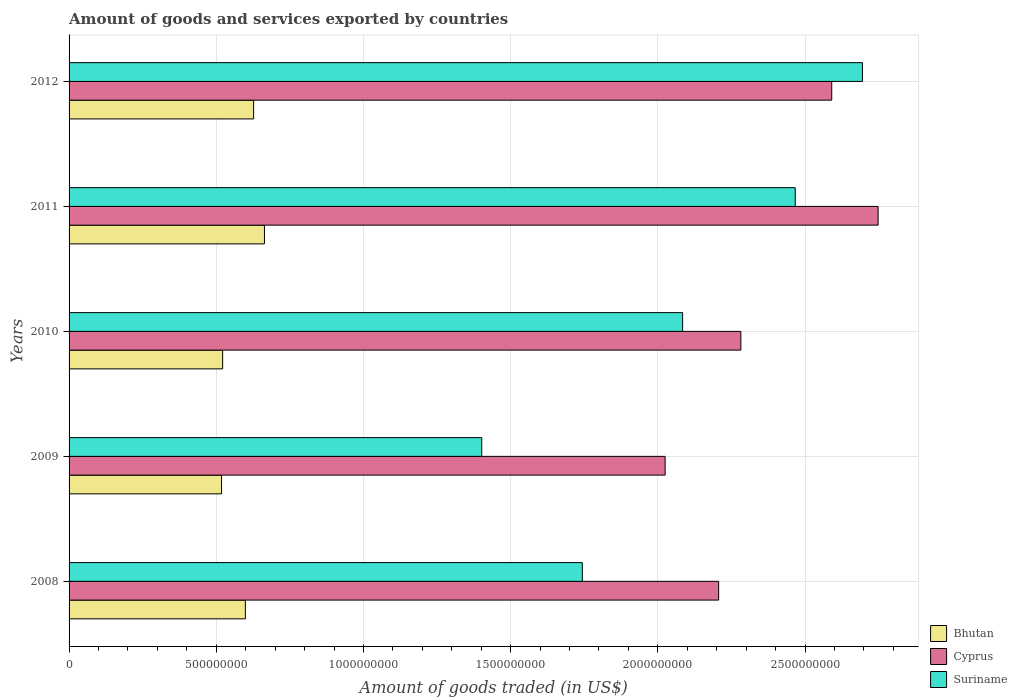How many groups of bars are there?
Keep it short and to the point. 5. Are the number of bars per tick equal to the number of legend labels?
Provide a short and direct response. Yes. Are the number of bars on each tick of the Y-axis equal?
Provide a succinct answer. Yes. What is the label of the 2nd group of bars from the top?
Your answer should be compact. 2011. What is the total amount of goods and services exported in Bhutan in 2012?
Provide a succinct answer. 6.27e+08. Across all years, what is the maximum total amount of goods and services exported in Bhutan?
Provide a succinct answer. 6.64e+08. Across all years, what is the minimum total amount of goods and services exported in Cyprus?
Your answer should be very brief. 2.02e+09. In which year was the total amount of goods and services exported in Bhutan minimum?
Make the answer very short. 2009. What is the total total amount of goods and services exported in Suriname in the graph?
Ensure brevity in your answer.  1.04e+1. What is the difference between the total amount of goods and services exported in Suriname in 2009 and that in 2010?
Provide a short and direct response. -6.82e+08. What is the difference between the total amount of goods and services exported in Cyprus in 2010 and the total amount of goods and services exported in Suriname in 2011?
Provide a succinct answer. -1.85e+08. What is the average total amount of goods and services exported in Bhutan per year?
Provide a succinct answer. 5.86e+08. In the year 2010, what is the difference between the total amount of goods and services exported in Cyprus and total amount of goods and services exported in Suriname?
Give a very brief answer. 1.98e+08. What is the ratio of the total amount of goods and services exported in Bhutan in 2009 to that in 2011?
Provide a short and direct response. 0.78. Is the total amount of goods and services exported in Bhutan in 2008 less than that in 2009?
Provide a succinct answer. No. Is the difference between the total amount of goods and services exported in Cyprus in 2008 and 2011 greater than the difference between the total amount of goods and services exported in Suriname in 2008 and 2011?
Your response must be concise. Yes. What is the difference between the highest and the second highest total amount of goods and services exported in Bhutan?
Provide a short and direct response. 3.68e+07. What is the difference between the highest and the lowest total amount of goods and services exported in Cyprus?
Offer a terse response. 7.23e+08. In how many years, is the total amount of goods and services exported in Suriname greater than the average total amount of goods and services exported in Suriname taken over all years?
Make the answer very short. 3. Is the sum of the total amount of goods and services exported in Suriname in 2008 and 2012 greater than the maximum total amount of goods and services exported in Bhutan across all years?
Make the answer very short. Yes. What does the 3rd bar from the top in 2009 represents?
Ensure brevity in your answer.  Bhutan. What does the 2nd bar from the bottom in 2009 represents?
Make the answer very short. Cyprus. How many bars are there?
Your response must be concise. 15. Are all the bars in the graph horizontal?
Ensure brevity in your answer.  Yes. How many years are there in the graph?
Your answer should be very brief. 5. Where does the legend appear in the graph?
Your response must be concise. Bottom right. How many legend labels are there?
Your response must be concise. 3. What is the title of the graph?
Provide a succinct answer. Amount of goods and services exported by countries. Does "Micronesia" appear as one of the legend labels in the graph?
Offer a very short reply. No. What is the label or title of the X-axis?
Give a very brief answer. Amount of goods traded (in US$). What is the label or title of the Y-axis?
Make the answer very short. Years. What is the Amount of goods traded (in US$) of Bhutan in 2008?
Offer a very short reply. 5.99e+08. What is the Amount of goods traded (in US$) of Cyprus in 2008?
Provide a short and direct response. 2.21e+09. What is the Amount of goods traded (in US$) in Suriname in 2008?
Give a very brief answer. 1.74e+09. What is the Amount of goods traded (in US$) in Bhutan in 2009?
Offer a very short reply. 5.18e+08. What is the Amount of goods traded (in US$) of Cyprus in 2009?
Your answer should be very brief. 2.02e+09. What is the Amount of goods traded (in US$) in Suriname in 2009?
Your answer should be compact. 1.40e+09. What is the Amount of goods traded (in US$) of Bhutan in 2010?
Make the answer very short. 5.22e+08. What is the Amount of goods traded (in US$) of Cyprus in 2010?
Provide a succinct answer. 2.28e+09. What is the Amount of goods traded (in US$) in Suriname in 2010?
Provide a succinct answer. 2.08e+09. What is the Amount of goods traded (in US$) of Bhutan in 2011?
Offer a very short reply. 6.64e+08. What is the Amount of goods traded (in US$) in Cyprus in 2011?
Your answer should be very brief. 2.75e+09. What is the Amount of goods traded (in US$) of Suriname in 2011?
Provide a short and direct response. 2.47e+09. What is the Amount of goods traded (in US$) in Bhutan in 2012?
Your answer should be very brief. 6.27e+08. What is the Amount of goods traded (in US$) of Cyprus in 2012?
Offer a terse response. 2.59e+09. What is the Amount of goods traded (in US$) of Suriname in 2012?
Provide a short and direct response. 2.69e+09. Across all years, what is the maximum Amount of goods traded (in US$) in Bhutan?
Your answer should be very brief. 6.64e+08. Across all years, what is the maximum Amount of goods traded (in US$) of Cyprus?
Give a very brief answer. 2.75e+09. Across all years, what is the maximum Amount of goods traded (in US$) in Suriname?
Provide a short and direct response. 2.69e+09. Across all years, what is the minimum Amount of goods traded (in US$) of Bhutan?
Provide a succinct answer. 5.18e+08. Across all years, what is the minimum Amount of goods traded (in US$) in Cyprus?
Give a very brief answer. 2.02e+09. Across all years, what is the minimum Amount of goods traded (in US$) in Suriname?
Offer a terse response. 1.40e+09. What is the total Amount of goods traded (in US$) in Bhutan in the graph?
Give a very brief answer. 2.93e+09. What is the total Amount of goods traded (in US$) in Cyprus in the graph?
Your response must be concise. 1.19e+1. What is the total Amount of goods traded (in US$) in Suriname in the graph?
Offer a terse response. 1.04e+1. What is the difference between the Amount of goods traded (in US$) in Bhutan in 2008 and that in 2009?
Make the answer very short. 8.09e+07. What is the difference between the Amount of goods traded (in US$) of Cyprus in 2008 and that in 2009?
Give a very brief answer. 1.82e+08. What is the difference between the Amount of goods traded (in US$) of Suriname in 2008 and that in 2009?
Ensure brevity in your answer.  3.42e+08. What is the difference between the Amount of goods traded (in US$) in Bhutan in 2008 and that in 2010?
Offer a very short reply. 7.72e+07. What is the difference between the Amount of goods traded (in US$) in Cyprus in 2008 and that in 2010?
Offer a very short reply. -7.54e+07. What is the difference between the Amount of goods traded (in US$) of Suriname in 2008 and that in 2010?
Give a very brief answer. -3.41e+08. What is the difference between the Amount of goods traded (in US$) in Bhutan in 2008 and that in 2011?
Provide a succinct answer. -6.48e+07. What is the difference between the Amount of goods traded (in US$) of Cyprus in 2008 and that in 2011?
Ensure brevity in your answer.  -5.42e+08. What is the difference between the Amount of goods traded (in US$) in Suriname in 2008 and that in 2011?
Give a very brief answer. -7.23e+08. What is the difference between the Amount of goods traded (in US$) in Bhutan in 2008 and that in 2012?
Provide a short and direct response. -2.80e+07. What is the difference between the Amount of goods traded (in US$) of Cyprus in 2008 and that in 2012?
Keep it short and to the point. -3.84e+08. What is the difference between the Amount of goods traded (in US$) of Suriname in 2008 and that in 2012?
Keep it short and to the point. -9.51e+08. What is the difference between the Amount of goods traded (in US$) of Bhutan in 2009 and that in 2010?
Your answer should be compact. -3.70e+06. What is the difference between the Amount of goods traded (in US$) of Cyprus in 2009 and that in 2010?
Offer a very short reply. -2.57e+08. What is the difference between the Amount of goods traded (in US$) of Suriname in 2009 and that in 2010?
Your answer should be very brief. -6.82e+08. What is the difference between the Amount of goods traded (in US$) in Bhutan in 2009 and that in 2011?
Your response must be concise. -1.46e+08. What is the difference between the Amount of goods traded (in US$) in Cyprus in 2009 and that in 2011?
Give a very brief answer. -7.23e+08. What is the difference between the Amount of goods traded (in US$) in Suriname in 2009 and that in 2011?
Provide a short and direct response. -1.06e+09. What is the difference between the Amount of goods traded (in US$) of Bhutan in 2009 and that in 2012?
Provide a succinct answer. -1.09e+08. What is the difference between the Amount of goods traded (in US$) in Cyprus in 2009 and that in 2012?
Ensure brevity in your answer.  -5.66e+08. What is the difference between the Amount of goods traded (in US$) in Suriname in 2009 and that in 2012?
Keep it short and to the point. -1.29e+09. What is the difference between the Amount of goods traded (in US$) in Bhutan in 2010 and that in 2011?
Ensure brevity in your answer.  -1.42e+08. What is the difference between the Amount of goods traded (in US$) of Cyprus in 2010 and that in 2011?
Offer a very short reply. -4.66e+08. What is the difference between the Amount of goods traded (in US$) in Suriname in 2010 and that in 2011?
Ensure brevity in your answer.  -3.83e+08. What is the difference between the Amount of goods traded (in US$) in Bhutan in 2010 and that in 2012?
Your response must be concise. -1.05e+08. What is the difference between the Amount of goods traded (in US$) of Cyprus in 2010 and that in 2012?
Provide a succinct answer. -3.09e+08. What is the difference between the Amount of goods traded (in US$) in Suriname in 2010 and that in 2012?
Provide a succinct answer. -6.11e+08. What is the difference between the Amount of goods traded (in US$) in Bhutan in 2011 and that in 2012?
Provide a succinct answer. 3.68e+07. What is the difference between the Amount of goods traded (in US$) in Cyprus in 2011 and that in 2012?
Keep it short and to the point. 1.58e+08. What is the difference between the Amount of goods traded (in US$) in Suriname in 2011 and that in 2012?
Your response must be concise. -2.28e+08. What is the difference between the Amount of goods traded (in US$) of Bhutan in 2008 and the Amount of goods traded (in US$) of Cyprus in 2009?
Provide a short and direct response. -1.43e+09. What is the difference between the Amount of goods traded (in US$) in Bhutan in 2008 and the Amount of goods traded (in US$) in Suriname in 2009?
Give a very brief answer. -8.03e+08. What is the difference between the Amount of goods traded (in US$) of Cyprus in 2008 and the Amount of goods traded (in US$) of Suriname in 2009?
Offer a very short reply. 8.05e+08. What is the difference between the Amount of goods traded (in US$) of Bhutan in 2008 and the Amount of goods traded (in US$) of Cyprus in 2010?
Offer a terse response. -1.68e+09. What is the difference between the Amount of goods traded (in US$) of Bhutan in 2008 and the Amount of goods traded (in US$) of Suriname in 2010?
Your answer should be compact. -1.49e+09. What is the difference between the Amount of goods traded (in US$) in Cyprus in 2008 and the Amount of goods traded (in US$) in Suriname in 2010?
Your answer should be compact. 1.22e+08. What is the difference between the Amount of goods traded (in US$) of Bhutan in 2008 and the Amount of goods traded (in US$) of Cyprus in 2011?
Your answer should be very brief. -2.15e+09. What is the difference between the Amount of goods traded (in US$) of Bhutan in 2008 and the Amount of goods traded (in US$) of Suriname in 2011?
Give a very brief answer. -1.87e+09. What is the difference between the Amount of goods traded (in US$) of Cyprus in 2008 and the Amount of goods traded (in US$) of Suriname in 2011?
Offer a terse response. -2.60e+08. What is the difference between the Amount of goods traded (in US$) of Bhutan in 2008 and the Amount of goods traded (in US$) of Cyprus in 2012?
Provide a short and direct response. -1.99e+09. What is the difference between the Amount of goods traded (in US$) of Bhutan in 2008 and the Amount of goods traded (in US$) of Suriname in 2012?
Your answer should be compact. -2.10e+09. What is the difference between the Amount of goods traded (in US$) in Cyprus in 2008 and the Amount of goods traded (in US$) in Suriname in 2012?
Provide a succinct answer. -4.88e+08. What is the difference between the Amount of goods traded (in US$) of Bhutan in 2009 and the Amount of goods traded (in US$) of Cyprus in 2010?
Offer a very short reply. -1.76e+09. What is the difference between the Amount of goods traded (in US$) in Bhutan in 2009 and the Amount of goods traded (in US$) in Suriname in 2010?
Your answer should be compact. -1.57e+09. What is the difference between the Amount of goods traded (in US$) in Cyprus in 2009 and the Amount of goods traded (in US$) in Suriname in 2010?
Offer a very short reply. -5.94e+07. What is the difference between the Amount of goods traded (in US$) in Bhutan in 2009 and the Amount of goods traded (in US$) in Cyprus in 2011?
Offer a very short reply. -2.23e+09. What is the difference between the Amount of goods traded (in US$) in Bhutan in 2009 and the Amount of goods traded (in US$) in Suriname in 2011?
Ensure brevity in your answer.  -1.95e+09. What is the difference between the Amount of goods traded (in US$) of Cyprus in 2009 and the Amount of goods traded (in US$) of Suriname in 2011?
Offer a terse response. -4.42e+08. What is the difference between the Amount of goods traded (in US$) of Bhutan in 2009 and the Amount of goods traded (in US$) of Cyprus in 2012?
Provide a short and direct response. -2.07e+09. What is the difference between the Amount of goods traded (in US$) of Bhutan in 2009 and the Amount of goods traded (in US$) of Suriname in 2012?
Offer a very short reply. -2.18e+09. What is the difference between the Amount of goods traded (in US$) of Cyprus in 2009 and the Amount of goods traded (in US$) of Suriname in 2012?
Provide a succinct answer. -6.70e+08. What is the difference between the Amount of goods traded (in US$) of Bhutan in 2010 and the Amount of goods traded (in US$) of Cyprus in 2011?
Provide a short and direct response. -2.23e+09. What is the difference between the Amount of goods traded (in US$) in Bhutan in 2010 and the Amount of goods traded (in US$) in Suriname in 2011?
Give a very brief answer. -1.95e+09. What is the difference between the Amount of goods traded (in US$) in Cyprus in 2010 and the Amount of goods traded (in US$) in Suriname in 2011?
Your answer should be compact. -1.85e+08. What is the difference between the Amount of goods traded (in US$) in Bhutan in 2010 and the Amount of goods traded (in US$) in Cyprus in 2012?
Provide a succinct answer. -2.07e+09. What is the difference between the Amount of goods traded (in US$) in Bhutan in 2010 and the Amount of goods traded (in US$) in Suriname in 2012?
Give a very brief answer. -2.17e+09. What is the difference between the Amount of goods traded (in US$) of Cyprus in 2010 and the Amount of goods traded (in US$) of Suriname in 2012?
Make the answer very short. -4.13e+08. What is the difference between the Amount of goods traded (in US$) of Bhutan in 2011 and the Amount of goods traded (in US$) of Cyprus in 2012?
Your answer should be compact. -1.93e+09. What is the difference between the Amount of goods traded (in US$) of Bhutan in 2011 and the Amount of goods traded (in US$) of Suriname in 2012?
Offer a terse response. -2.03e+09. What is the difference between the Amount of goods traded (in US$) in Cyprus in 2011 and the Amount of goods traded (in US$) in Suriname in 2012?
Provide a succinct answer. 5.32e+07. What is the average Amount of goods traded (in US$) of Bhutan per year?
Give a very brief answer. 5.86e+08. What is the average Amount of goods traded (in US$) of Cyprus per year?
Offer a very short reply. 2.37e+09. What is the average Amount of goods traded (in US$) of Suriname per year?
Your answer should be compact. 2.08e+09. In the year 2008, what is the difference between the Amount of goods traded (in US$) of Bhutan and Amount of goods traded (in US$) of Cyprus?
Provide a succinct answer. -1.61e+09. In the year 2008, what is the difference between the Amount of goods traded (in US$) of Bhutan and Amount of goods traded (in US$) of Suriname?
Offer a very short reply. -1.14e+09. In the year 2008, what is the difference between the Amount of goods traded (in US$) in Cyprus and Amount of goods traded (in US$) in Suriname?
Your answer should be compact. 4.63e+08. In the year 2009, what is the difference between the Amount of goods traded (in US$) in Bhutan and Amount of goods traded (in US$) in Cyprus?
Make the answer very short. -1.51e+09. In the year 2009, what is the difference between the Amount of goods traded (in US$) in Bhutan and Amount of goods traded (in US$) in Suriname?
Provide a succinct answer. -8.84e+08. In the year 2009, what is the difference between the Amount of goods traded (in US$) of Cyprus and Amount of goods traded (in US$) of Suriname?
Your answer should be compact. 6.23e+08. In the year 2010, what is the difference between the Amount of goods traded (in US$) of Bhutan and Amount of goods traded (in US$) of Cyprus?
Offer a terse response. -1.76e+09. In the year 2010, what is the difference between the Amount of goods traded (in US$) of Bhutan and Amount of goods traded (in US$) of Suriname?
Make the answer very short. -1.56e+09. In the year 2010, what is the difference between the Amount of goods traded (in US$) in Cyprus and Amount of goods traded (in US$) in Suriname?
Your response must be concise. 1.98e+08. In the year 2011, what is the difference between the Amount of goods traded (in US$) in Bhutan and Amount of goods traded (in US$) in Cyprus?
Make the answer very short. -2.08e+09. In the year 2011, what is the difference between the Amount of goods traded (in US$) in Bhutan and Amount of goods traded (in US$) in Suriname?
Your answer should be compact. -1.80e+09. In the year 2011, what is the difference between the Amount of goods traded (in US$) in Cyprus and Amount of goods traded (in US$) in Suriname?
Offer a very short reply. 2.81e+08. In the year 2012, what is the difference between the Amount of goods traded (in US$) of Bhutan and Amount of goods traded (in US$) of Cyprus?
Your answer should be compact. -1.96e+09. In the year 2012, what is the difference between the Amount of goods traded (in US$) in Bhutan and Amount of goods traded (in US$) in Suriname?
Your answer should be very brief. -2.07e+09. In the year 2012, what is the difference between the Amount of goods traded (in US$) of Cyprus and Amount of goods traded (in US$) of Suriname?
Your answer should be very brief. -1.04e+08. What is the ratio of the Amount of goods traded (in US$) in Bhutan in 2008 to that in 2009?
Give a very brief answer. 1.16. What is the ratio of the Amount of goods traded (in US$) of Cyprus in 2008 to that in 2009?
Your response must be concise. 1.09. What is the ratio of the Amount of goods traded (in US$) in Suriname in 2008 to that in 2009?
Offer a very short reply. 1.24. What is the ratio of the Amount of goods traded (in US$) of Bhutan in 2008 to that in 2010?
Give a very brief answer. 1.15. What is the ratio of the Amount of goods traded (in US$) of Cyprus in 2008 to that in 2010?
Give a very brief answer. 0.97. What is the ratio of the Amount of goods traded (in US$) of Suriname in 2008 to that in 2010?
Your answer should be very brief. 0.84. What is the ratio of the Amount of goods traded (in US$) of Bhutan in 2008 to that in 2011?
Provide a succinct answer. 0.9. What is the ratio of the Amount of goods traded (in US$) of Cyprus in 2008 to that in 2011?
Keep it short and to the point. 0.8. What is the ratio of the Amount of goods traded (in US$) of Suriname in 2008 to that in 2011?
Give a very brief answer. 0.71. What is the ratio of the Amount of goods traded (in US$) in Bhutan in 2008 to that in 2012?
Ensure brevity in your answer.  0.96. What is the ratio of the Amount of goods traded (in US$) in Cyprus in 2008 to that in 2012?
Keep it short and to the point. 0.85. What is the ratio of the Amount of goods traded (in US$) in Suriname in 2008 to that in 2012?
Make the answer very short. 0.65. What is the ratio of the Amount of goods traded (in US$) in Bhutan in 2009 to that in 2010?
Make the answer very short. 0.99. What is the ratio of the Amount of goods traded (in US$) in Cyprus in 2009 to that in 2010?
Offer a terse response. 0.89. What is the ratio of the Amount of goods traded (in US$) of Suriname in 2009 to that in 2010?
Give a very brief answer. 0.67. What is the ratio of the Amount of goods traded (in US$) in Bhutan in 2009 to that in 2011?
Offer a terse response. 0.78. What is the ratio of the Amount of goods traded (in US$) in Cyprus in 2009 to that in 2011?
Your answer should be compact. 0.74. What is the ratio of the Amount of goods traded (in US$) of Suriname in 2009 to that in 2011?
Keep it short and to the point. 0.57. What is the ratio of the Amount of goods traded (in US$) of Bhutan in 2009 to that in 2012?
Make the answer very short. 0.83. What is the ratio of the Amount of goods traded (in US$) of Cyprus in 2009 to that in 2012?
Provide a succinct answer. 0.78. What is the ratio of the Amount of goods traded (in US$) in Suriname in 2009 to that in 2012?
Your response must be concise. 0.52. What is the ratio of the Amount of goods traded (in US$) of Bhutan in 2010 to that in 2011?
Provide a succinct answer. 0.79. What is the ratio of the Amount of goods traded (in US$) of Cyprus in 2010 to that in 2011?
Provide a succinct answer. 0.83. What is the ratio of the Amount of goods traded (in US$) of Suriname in 2010 to that in 2011?
Provide a short and direct response. 0.84. What is the ratio of the Amount of goods traded (in US$) of Bhutan in 2010 to that in 2012?
Your answer should be very brief. 0.83. What is the ratio of the Amount of goods traded (in US$) in Cyprus in 2010 to that in 2012?
Give a very brief answer. 0.88. What is the ratio of the Amount of goods traded (in US$) of Suriname in 2010 to that in 2012?
Your response must be concise. 0.77. What is the ratio of the Amount of goods traded (in US$) of Bhutan in 2011 to that in 2012?
Your response must be concise. 1.06. What is the ratio of the Amount of goods traded (in US$) in Cyprus in 2011 to that in 2012?
Your answer should be very brief. 1.06. What is the ratio of the Amount of goods traded (in US$) of Suriname in 2011 to that in 2012?
Keep it short and to the point. 0.92. What is the difference between the highest and the second highest Amount of goods traded (in US$) of Bhutan?
Your answer should be compact. 3.68e+07. What is the difference between the highest and the second highest Amount of goods traded (in US$) in Cyprus?
Give a very brief answer. 1.58e+08. What is the difference between the highest and the second highest Amount of goods traded (in US$) of Suriname?
Keep it short and to the point. 2.28e+08. What is the difference between the highest and the lowest Amount of goods traded (in US$) of Bhutan?
Keep it short and to the point. 1.46e+08. What is the difference between the highest and the lowest Amount of goods traded (in US$) of Cyprus?
Give a very brief answer. 7.23e+08. What is the difference between the highest and the lowest Amount of goods traded (in US$) in Suriname?
Provide a succinct answer. 1.29e+09. 